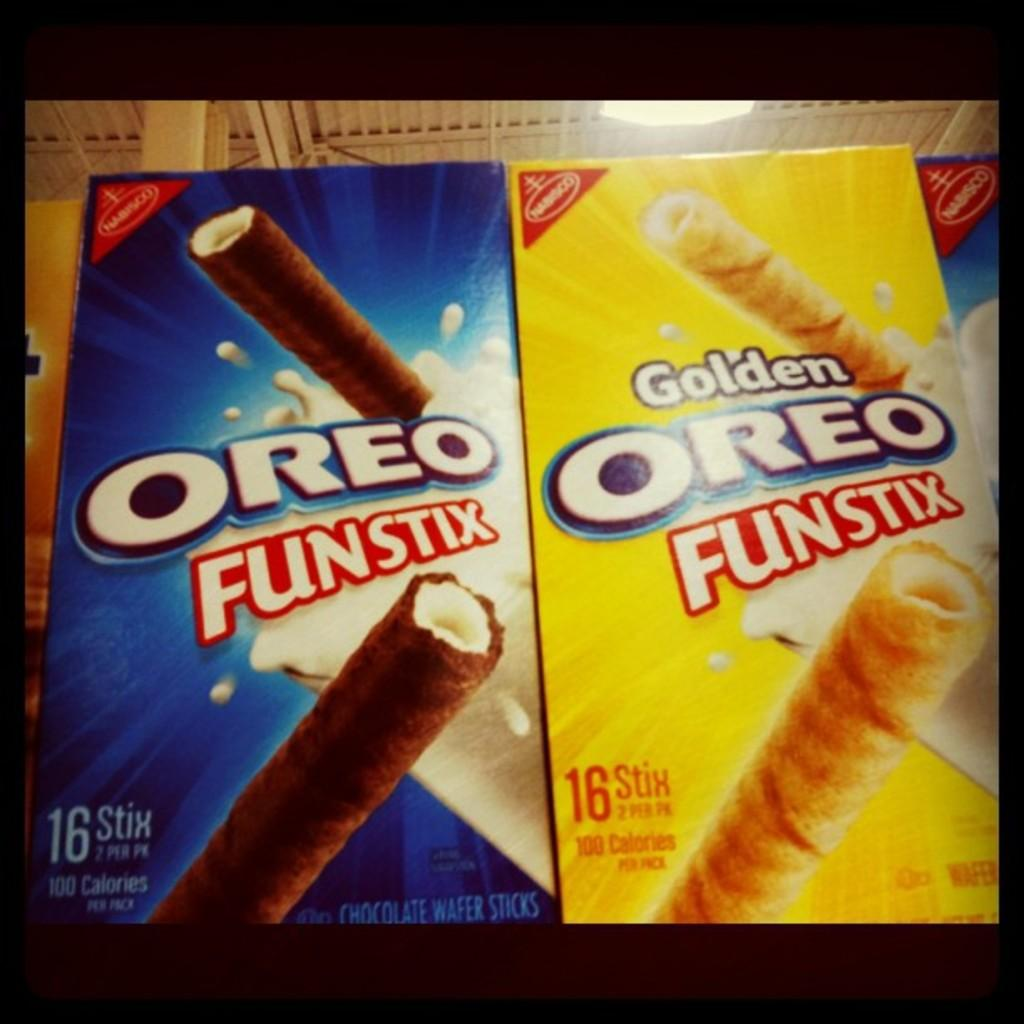What is the main subject in the foreground of the image? There is a screen in the foreground of the image. What is depicted on the screen? There are cardboard snack boxes on the screen. Can you describe the lighting in the image? There is a light near the ceiling in the background. How many planes can be seen flying in the image? There are no planes visible in the image. What type of legs are visible in the image? There are no legs visible in the image. Is there a stove present in the image? There is no stove present in the image. 